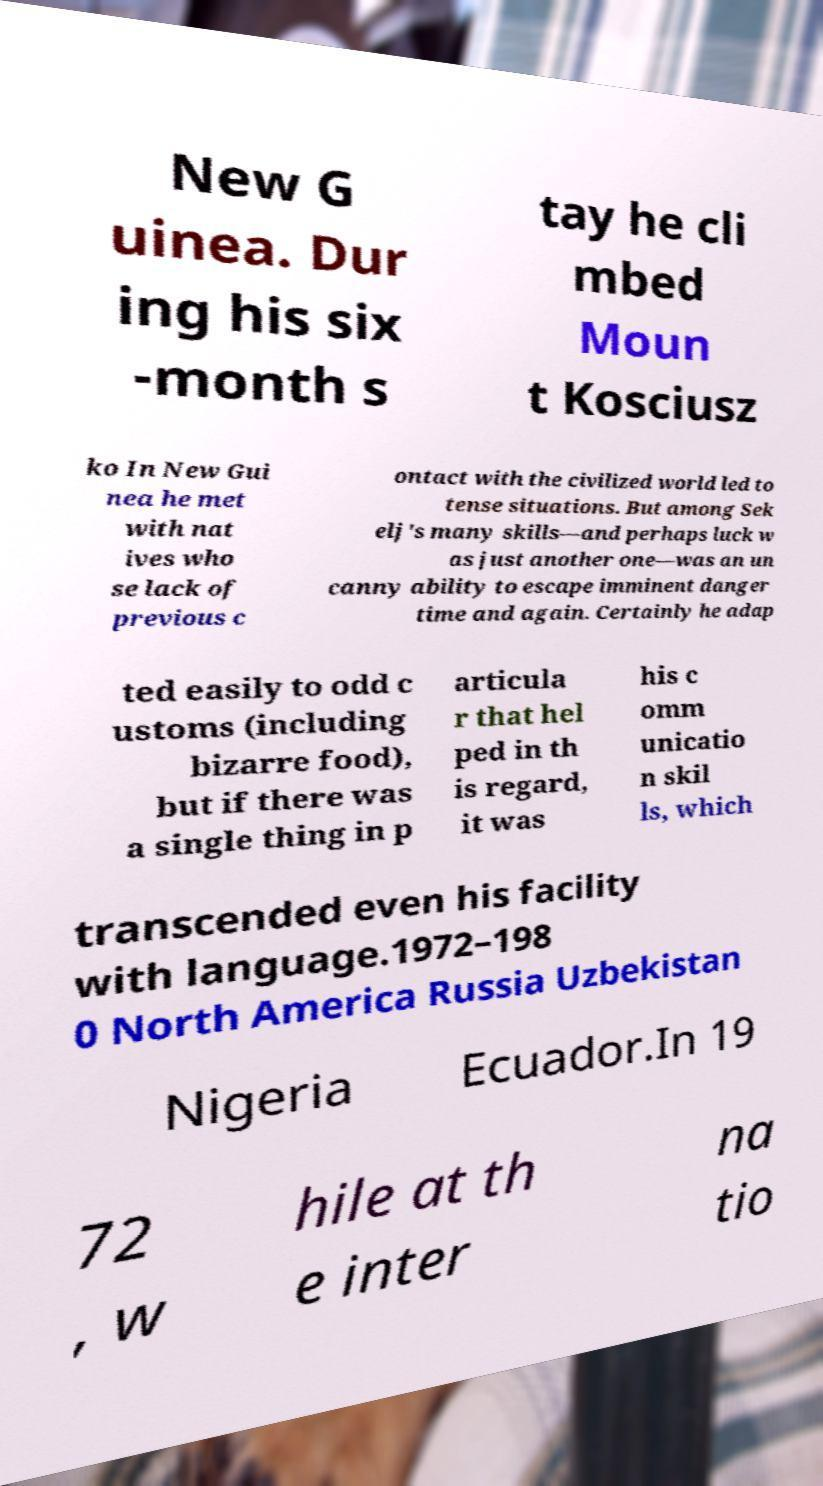Could you extract and type out the text from this image? New G uinea. Dur ing his six -month s tay he cli mbed Moun t Kosciusz ko In New Gui nea he met with nat ives who se lack of previous c ontact with the civilized world led to tense situations. But among Sek elj's many skills—and perhaps luck w as just another one—was an un canny ability to escape imminent danger time and again. Certainly he adap ted easily to odd c ustoms (including bizarre food), but if there was a single thing in p articula r that hel ped in th is regard, it was his c omm unicatio n skil ls, which transcended even his facility with language.1972–198 0 North America Russia Uzbekistan Nigeria Ecuador.In 19 72 , w hile at th e inter na tio 